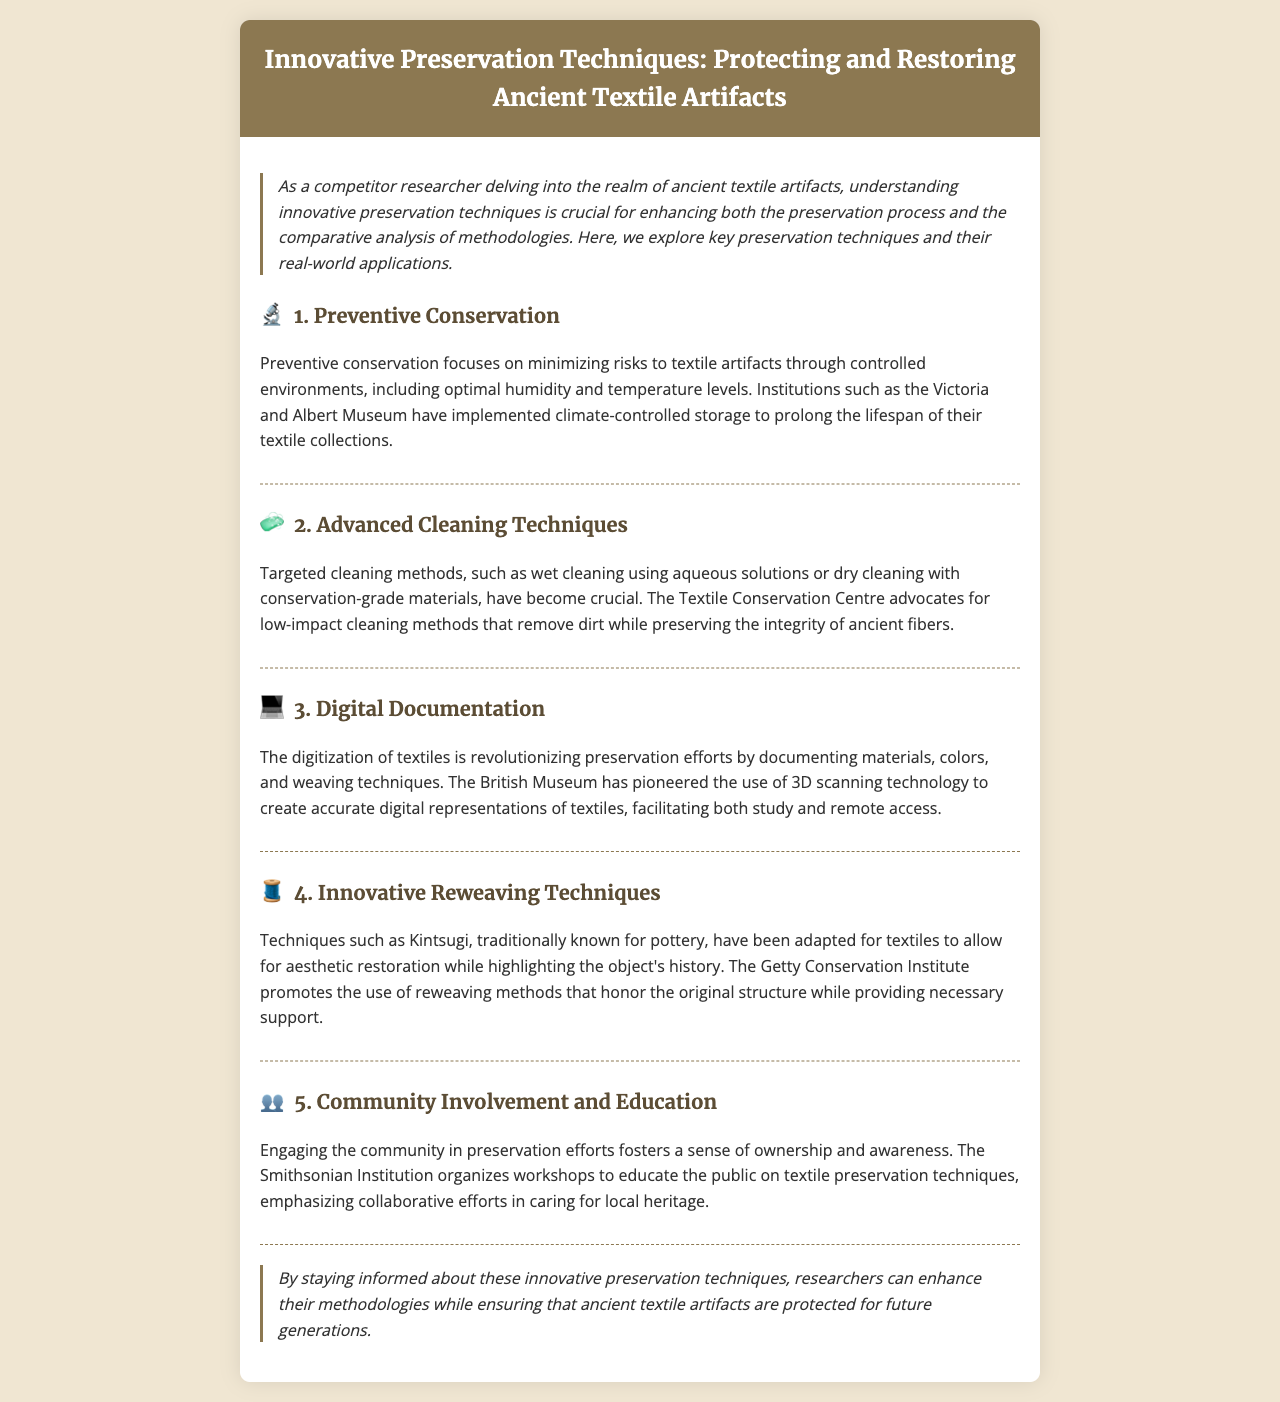What is the title of the brochure? The title is found in the header of the document.
Answer: Innovative Preservation Techniques: Protecting and Restoring Ancient Textile Artifacts Which museum implemented climate-controlled storage? This information is located in the section discussing preventive conservation.
Answer: Victoria and Albert Museum What cleaning method does the Textile Conservation Centre advocate for? The document specifies the preferred cleaning method in the advanced cleaning techniques section.
Answer: Low-impact cleaning methods What technology does the British Museum use for digitization? This detail is mentioned in the section about digital documentation.
Answer: 3D scanning technology What innovative technique for textiles is adapted from pottery? This information can be found in the section discussing innovative reweaving techniques.
Answer: Kintsugi How does the Smithsonian Institution engage the community? The engagement method is described in the community involvement section.
Answer: Workshops What is the main goal of preventive conservation? This goal is inferred from the introductory paragraph on preservation techniques.
Answer: Minimize risks What is emphasized as part of community preservation efforts? The emphasis of community efforts is provided in the last section of the document.
Answer: Awareness 